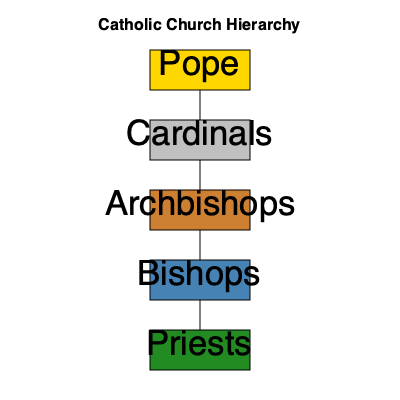In the Catholic Church hierarchy, which position is directly below the Pope and serves as his primary advisors? To answer this question, let's examine the Catholic Church hierarchy as shown in the organizational diagram:

1. At the top of the hierarchy is the Pope, who is the supreme leader of the Catholic Church.
2. Directly below the Pope are the Cardinals, represented in silver.
3. Cardinals are followed by Archbishops, then Bishops, and finally Priests.

The position of Cardinal is particularly significant because:

1. Cardinals are appointed by the Pope and serve as his principal advisors.
2. They assist the Pope in the governance of the universal Church.
3. Cardinals under the age of 80 are also responsible for electing a new Pope when the position becomes vacant.

While Archbishops and Bishops also have important roles in Church leadership, it is the Cardinals who work most closely with the Pope and are considered his immediate subordinates in the Church hierarchy.
Answer: Cardinals 